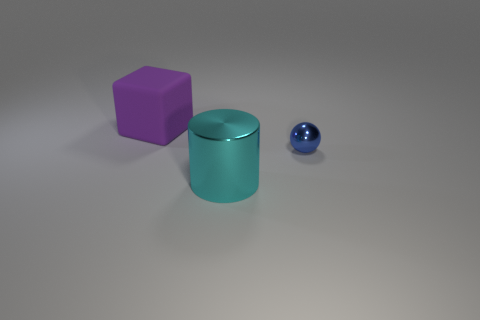Add 3 large purple matte cubes. How many objects exist? 6 Subtract all cylinders. How many objects are left? 2 Add 2 small green rubber cylinders. How many small green rubber cylinders exist? 2 Subtract 0 cyan balls. How many objects are left? 3 Subtract all balls. Subtract all metal objects. How many objects are left? 0 Add 2 purple cubes. How many purple cubes are left? 3 